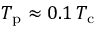<formula> <loc_0><loc_0><loc_500><loc_500>T _ { p } \approx 0 . 1 \, T _ { c }</formula> 